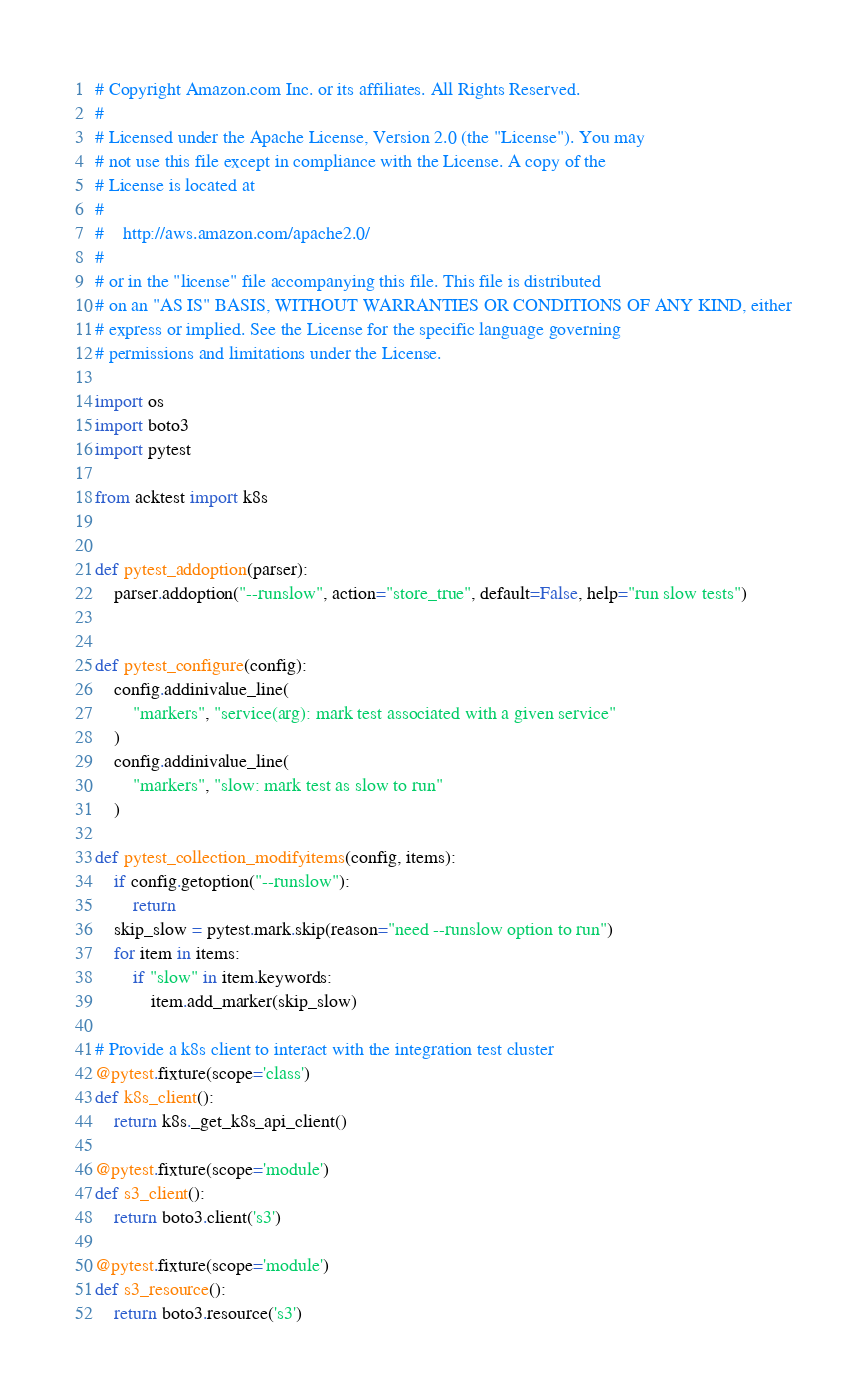Convert code to text. <code><loc_0><loc_0><loc_500><loc_500><_Python_># Copyright Amazon.com Inc. or its affiliates. All Rights Reserved.
#
# Licensed under the Apache License, Version 2.0 (the "License"). You may
# not use this file except in compliance with the License. A copy of the
# License is located at
#
#	 http://aws.amazon.com/apache2.0/
#
# or in the "license" file accompanying this file. This file is distributed
# on an "AS IS" BASIS, WITHOUT WARRANTIES OR CONDITIONS OF ANY KIND, either
# express or implied. See the License for the specific language governing
# permissions and limitations under the License.

import os
import boto3
import pytest

from acktest import k8s


def pytest_addoption(parser):
    parser.addoption("--runslow", action="store_true", default=False, help="run slow tests")


def pytest_configure(config):
    config.addinivalue_line(
        "markers", "service(arg): mark test associated with a given service"
    )
    config.addinivalue_line(
        "markers", "slow: mark test as slow to run"
    )

def pytest_collection_modifyitems(config, items):
    if config.getoption("--runslow"):
        return
    skip_slow = pytest.mark.skip(reason="need --runslow option to run")
    for item in items:
        if "slow" in item.keywords:
            item.add_marker(skip_slow)

# Provide a k8s client to interact with the integration test cluster
@pytest.fixture(scope='class')
def k8s_client():
    return k8s._get_k8s_api_client()

@pytest.fixture(scope='module')
def s3_client():
    return boto3.client('s3')

@pytest.fixture(scope='module')
def s3_resource():
    return boto3.resource('s3') </code> 